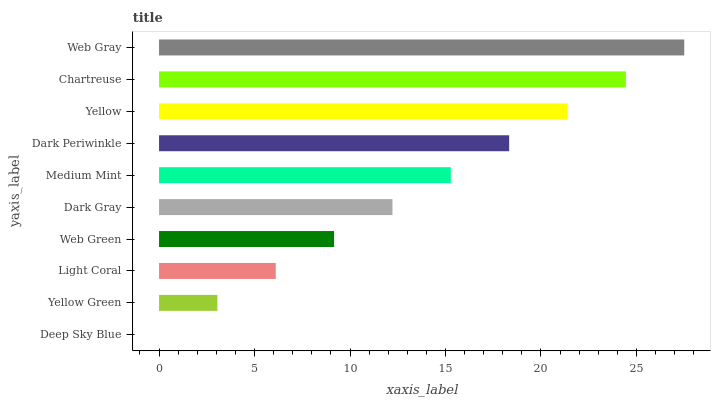Is Deep Sky Blue the minimum?
Answer yes or no. Yes. Is Web Gray the maximum?
Answer yes or no. Yes. Is Yellow Green the minimum?
Answer yes or no. No. Is Yellow Green the maximum?
Answer yes or no. No. Is Yellow Green greater than Deep Sky Blue?
Answer yes or no. Yes. Is Deep Sky Blue less than Yellow Green?
Answer yes or no. Yes. Is Deep Sky Blue greater than Yellow Green?
Answer yes or no. No. Is Yellow Green less than Deep Sky Blue?
Answer yes or no. No. Is Medium Mint the high median?
Answer yes or no. Yes. Is Dark Gray the low median?
Answer yes or no. Yes. Is Chartreuse the high median?
Answer yes or no. No. Is Medium Mint the low median?
Answer yes or no. No. 